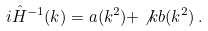Convert formula to latex. <formula><loc_0><loc_0><loc_500><loc_500>i \hat { H } ^ { - 1 } ( k ) = a ( k ^ { 2 } ) + \not k b ( k ^ { 2 } ) \, .</formula> 